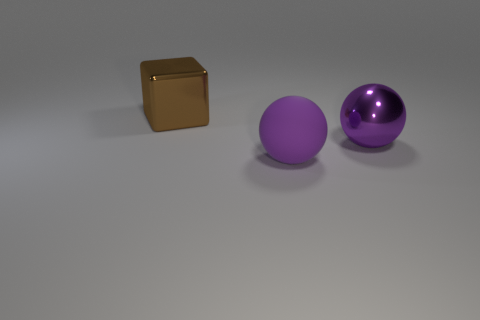Are there any other cubes that have the same material as the block?
Provide a short and direct response. No. Is the number of large things to the right of the big matte thing less than the number of purple matte objects?
Keep it short and to the point. No. There is a brown metallic cube left of the purple rubber object; is it the same size as the large matte object?
Make the answer very short. Yes. How many other brown things are the same shape as the large matte object?
Your answer should be very brief. 0. What size is the object that is the same material as the cube?
Your response must be concise. Large. Is the number of purple matte objects on the left side of the brown cube the same as the number of large purple balls?
Keep it short and to the point. No. Is the color of the metallic block the same as the big shiny ball?
Ensure brevity in your answer.  No. There is a large purple thing to the right of the large purple rubber ball; does it have the same shape as the object left of the large rubber ball?
Keep it short and to the point. No. There is another big purple thing that is the same shape as the rubber object; what is it made of?
Your answer should be compact. Metal. What color is the object that is behind the rubber sphere and left of the big metallic sphere?
Make the answer very short. Brown. 